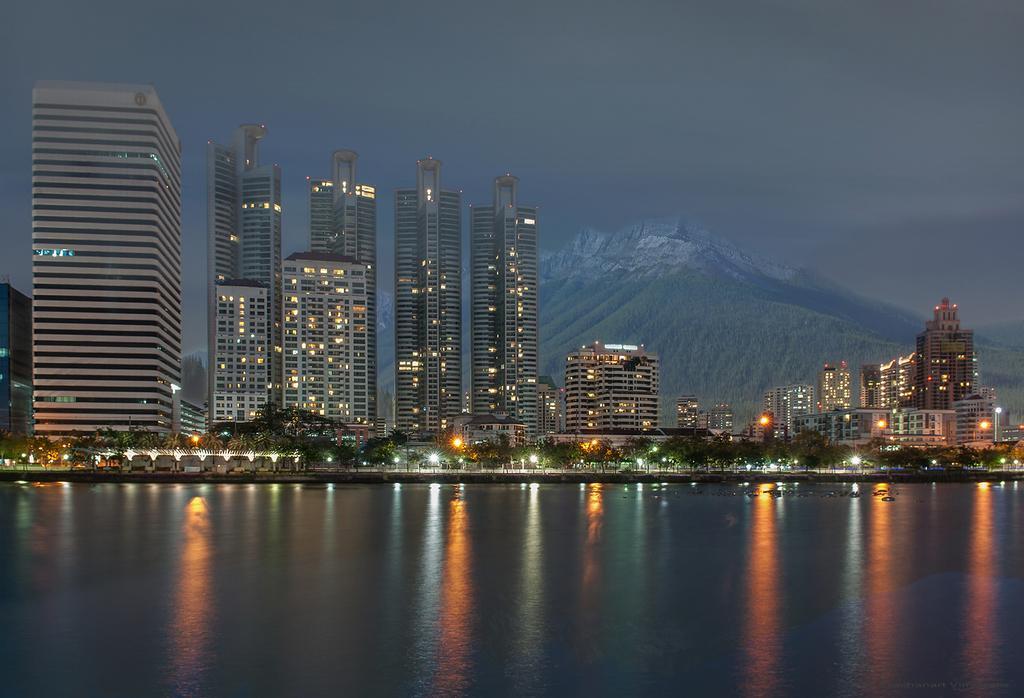How would you summarize this image in a sentence or two? In this picture we can observe a river. There are some tall buildings. We can observe some trees and lights. In the background there are hills and a sky. 